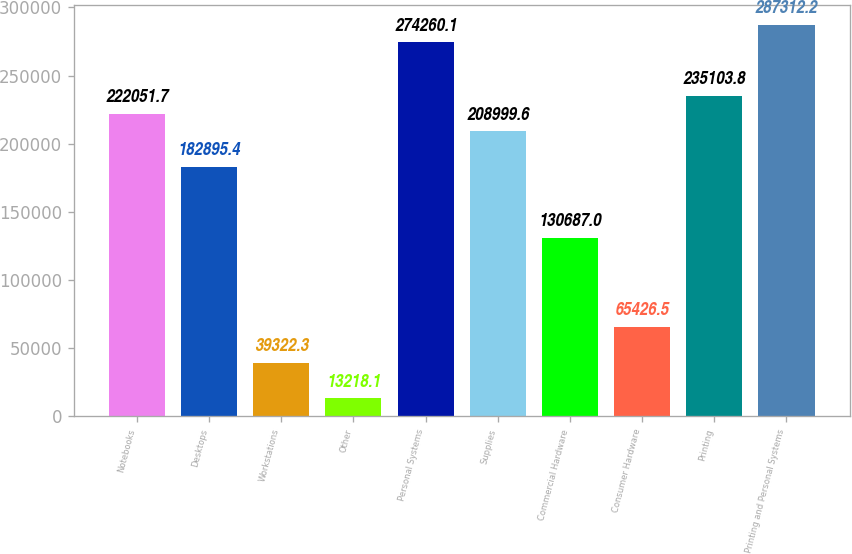Convert chart to OTSL. <chart><loc_0><loc_0><loc_500><loc_500><bar_chart><fcel>Notebooks<fcel>Desktops<fcel>Workstations<fcel>Other<fcel>Personal Systems<fcel>Supplies<fcel>Commercial Hardware<fcel>Consumer Hardware<fcel>Printing<fcel>Printing and Personal Systems<nl><fcel>222052<fcel>182895<fcel>39322.3<fcel>13218.1<fcel>274260<fcel>209000<fcel>130687<fcel>65426.5<fcel>235104<fcel>287312<nl></chart> 